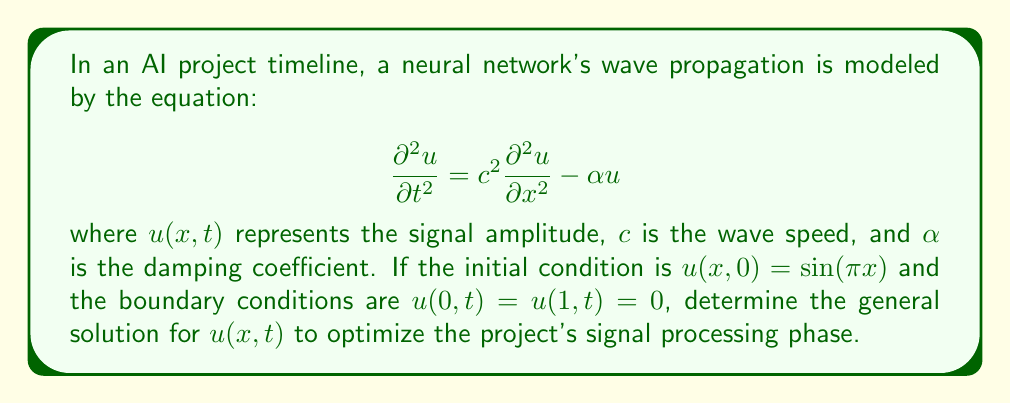Solve this math problem. To solve this wave equation with damping, we'll follow these steps:

1) Assume a solution of the form: $u(x,t) = X(x)T(t)$

2) Substitute this into the original equation:
   $$X(x)T''(t) = c^2X''(x)T(t) - \alpha X(x)T(t)$$

3) Separate variables:
   $$\frac{T''(t)}{T(t)} = c^2\frac{X''(x)}{X(x)} - \alpha = -\lambda$$
   where $\lambda$ is a separation constant.

4) Solve the spatial equation:
   $$X''(x) + \left(\frac{\lambda + \alpha}{c^2}\right)X(x) = 0$$
   With boundary conditions, this gives $X(x) = \sin(n\pi x)$ and $\lambda_n = (n\pi c)^2 - \alpha$

5) Solve the temporal equation:
   $$T''(t) + (\lambda_n + \alpha)T(t) = 0$$
   This gives $T(t) = e^{-\frac{\alpha t}{2}}(A_n\cos(\omega_n t) + B_n\sin(\omega_n t))$
   where $\omega_n = \sqrt{(n\pi c)^2 - \frac{\alpha^2}{4}}$

6) The general solution is:
   $$u(x,t) = \sum_{n=1}^{\infty} e^{-\frac{\alpha t}{2}}(A_n\cos(\omega_n t) + B_n\sin(\omega_n t))\sin(n\pi x)$$

7) Apply the initial condition:
   $u(x,0) = \sin(\pi x)$ implies $A_1 = 1$ and $A_n = 0$ for $n > 1$

8) The final solution is:
   $$u(x,t) = e^{-\frac{\alpha t}{2}}(\cos(\omega_1 t) + \frac{\alpha}{2\omega_1}\sin(\omega_1 t))\sin(\pi x)$$
   where $\omega_1 = \sqrt{(\pi c)^2 - \frac{\alpha^2}{4}}$
Answer: $u(x,t) = e^{-\frac{\alpha t}{2}}(\cos(\omega_1 t) + \frac{\alpha}{2\omega_1}\sin(\omega_1 t))\sin(\pi x)$, $\omega_1 = \sqrt{(\pi c)^2 - \frac{\alpha^2}{4}}$ 